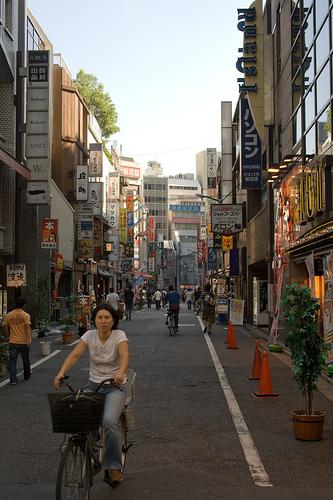How many people are on bikes?
Give a very brief answer. 2. Is this a vehicle?
Short answer required. No. How many cone you see in the picture?
Short answer required. 3. Does she have a basket on her bike?
Answer briefly. Yes. Are any of the people wearing a ponytail hairstyle?
Write a very short answer. No. Is the woman smiling?
Quick response, please. No. Has it been raining?
Short answer required. No. How many trees are there?
Keep it brief. 2. Is there a sidewalk?
Short answer required. No. Are any cars visible?
Be succinct. No. Is anyone riding the bike?
Quick response, please. Yes. Is it raining?
Quick response, please. No. Is she wearing a safety vest?
Quick response, please. No. Who is cycling?
Keep it brief. Woman. Is the road busy?
Keep it brief. Yes. Is this Chinatown?
Give a very brief answer. Yes. What color is the boy's shirt?
Write a very short answer. White. What traffic practice is she emphasizing?
Quick response, please. None. What is the woman riding on?
Give a very brief answer. Bike. Is the cyclist traveling toward or away from us?
Quick response, please. Toward. What is this lady doing?
Concise answer only. Riding bike. Where is a traffic cone?
Short answer required. On right. What is the woman dressed in?
Concise answer only. Shirt and pants. Is the rider using proper personal protective equipment?
Answer briefly. No. Is the rider wearing safety equipment?
Answer briefly. No. 